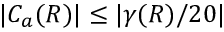<formula> <loc_0><loc_0><loc_500><loc_500>| C _ { a } ( R ) | \leq | \gamma ( R ) / 2 0 |</formula> 